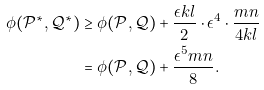<formula> <loc_0><loc_0><loc_500><loc_500>\phi ( \mathcal { P } ^ { * } , \mathcal { Q } ^ { * } ) & \geq \phi ( { \mathcal { P } } , { \mathcal { Q } } ) + \frac { \epsilon k l } { 2 } \cdot \epsilon ^ { 4 } \cdot \frac { m n } { 4 k l } \\ & = \phi ( \mathcal { P } , \mathcal { Q } ) + \frac { \epsilon ^ { 5 } m n } { 8 } .</formula> 